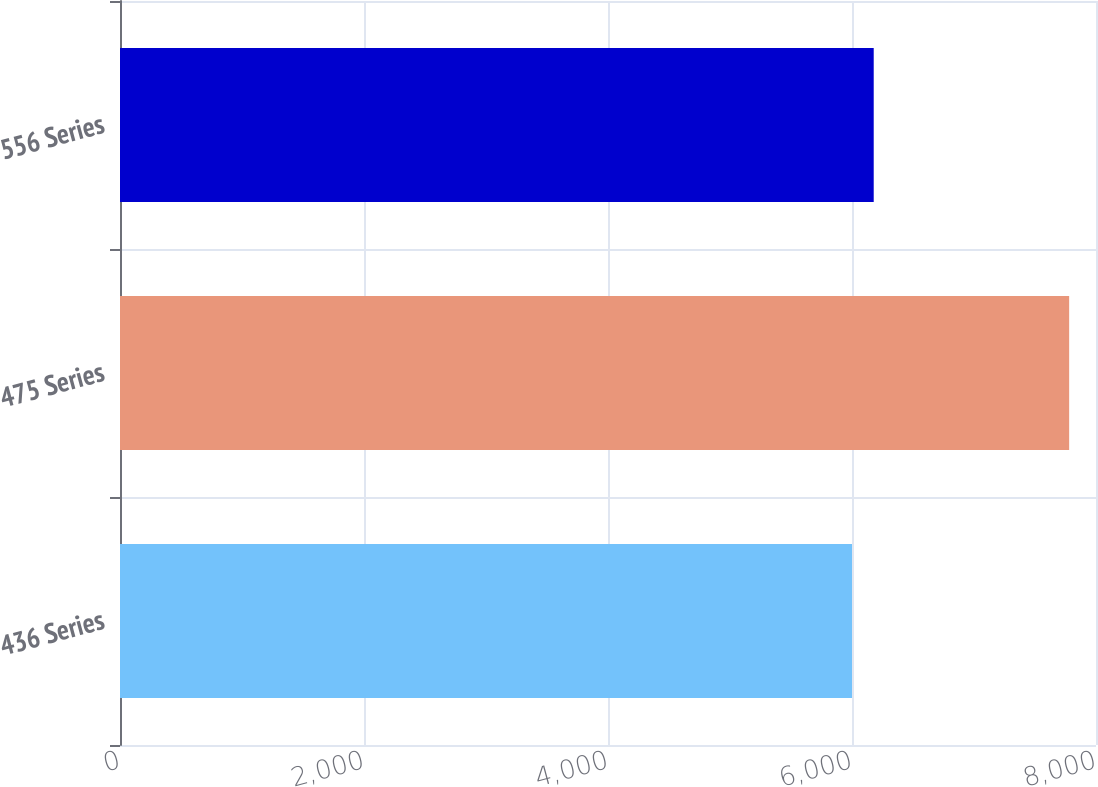<chart> <loc_0><loc_0><loc_500><loc_500><bar_chart><fcel>436 Series<fcel>475 Series<fcel>556 Series<nl><fcel>6000<fcel>7780<fcel>6178<nl></chart> 